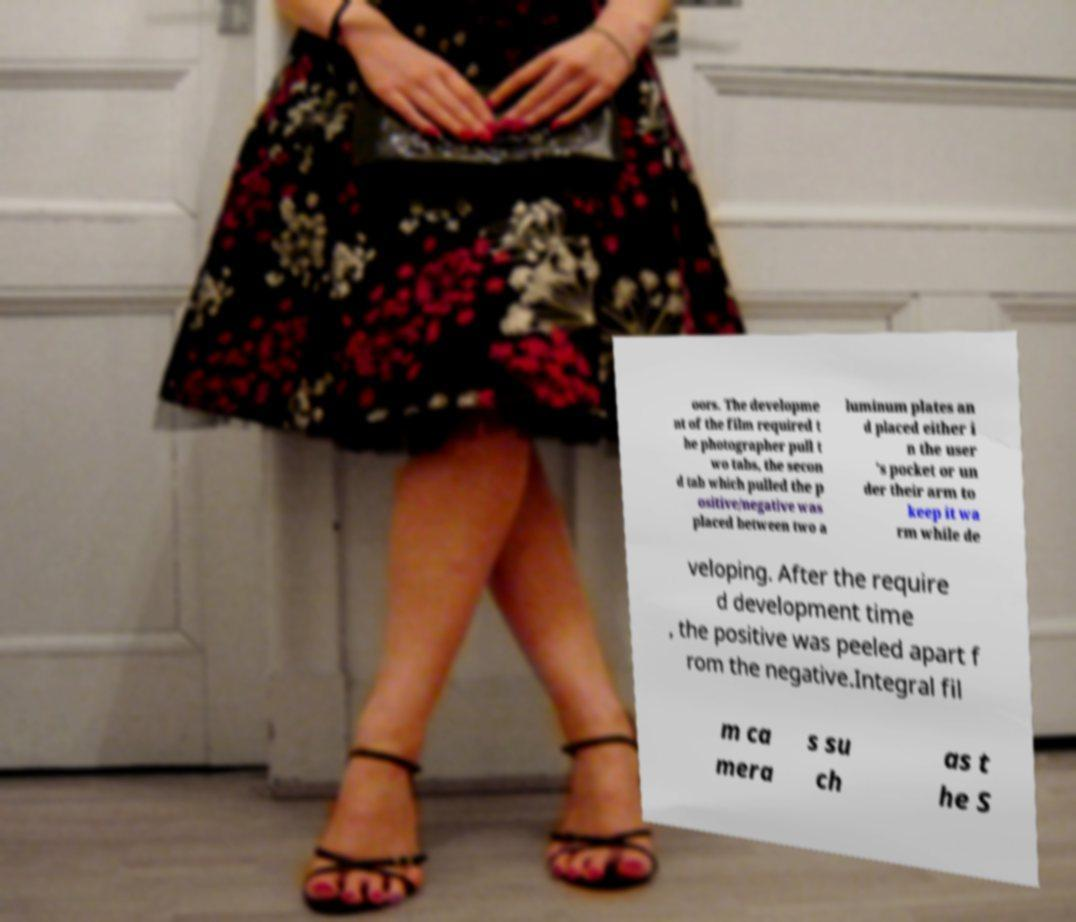Could you assist in decoding the text presented in this image and type it out clearly? oors. The developme nt of the film required t he photographer pull t wo tabs, the secon d tab which pulled the p ositive/negative was placed between two a luminum plates an d placed either i n the user 's pocket or un der their arm to keep it wa rm while de veloping. After the require d development time , the positive was peeled apart f rom the negative.Integral fil m ca mera s su ch as t he S 